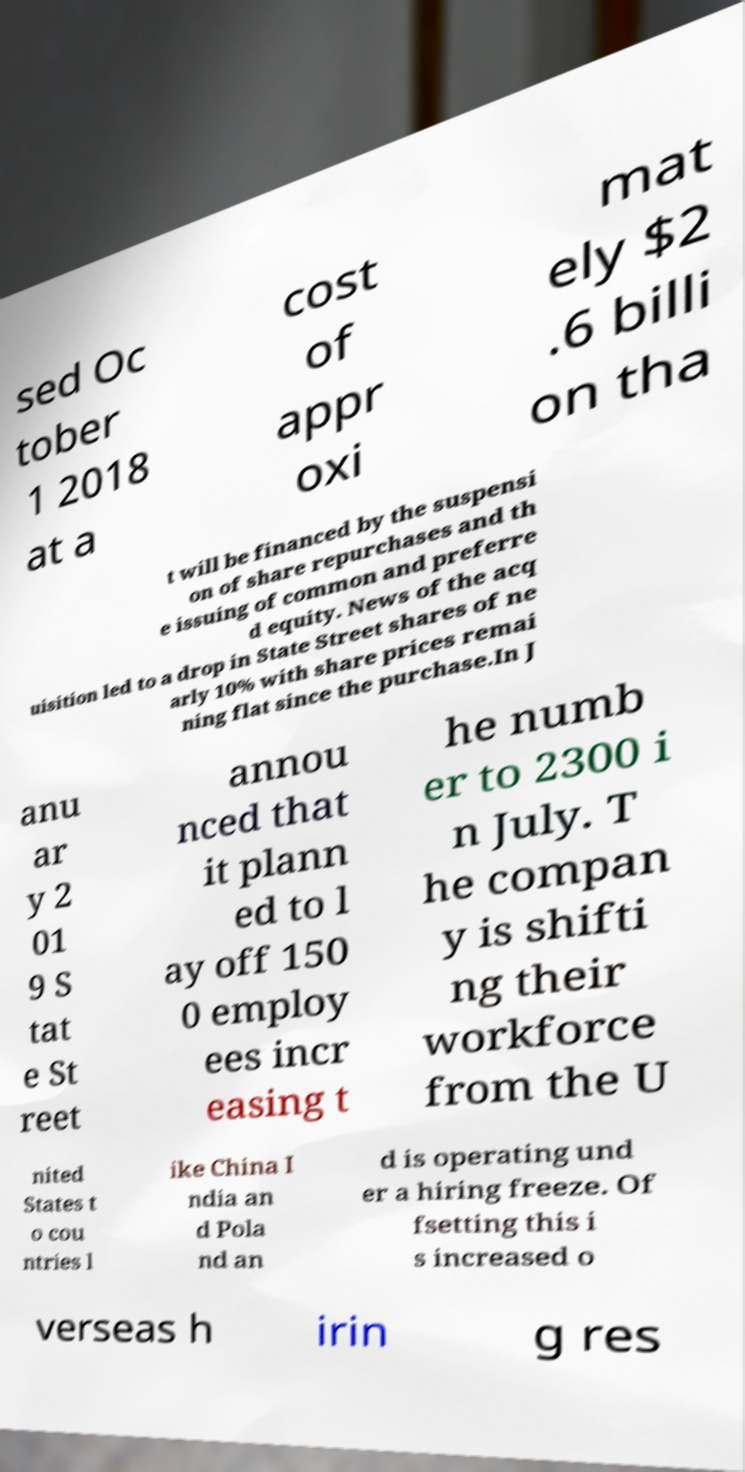I need the written content from this picture converted into text. Can you do that? sed Oc tober 1 2018 at a cost of appr oxi mat ely $2 .6 billi on tha t will be financed by the suspensi on of share repurchases and th e issuing of common and preferre d equity. News of the acq uisition led to a drop in State Street shares of ne arly 10% with share prices remai ning flat since the purchase.In J anu ar y 2 01 9 S tat e St reet annou nced that it plann ed to l ay off 150 0 employ ees incr easing t he numb er to 2300 i n July. T he compan y is shifti ng their workforce from the U nited States t o cou ntries l ike China I ndia an d Pola nd an d is operating und er a hiring freeze. Of fsetting this i s increased o verseas h irin g res 